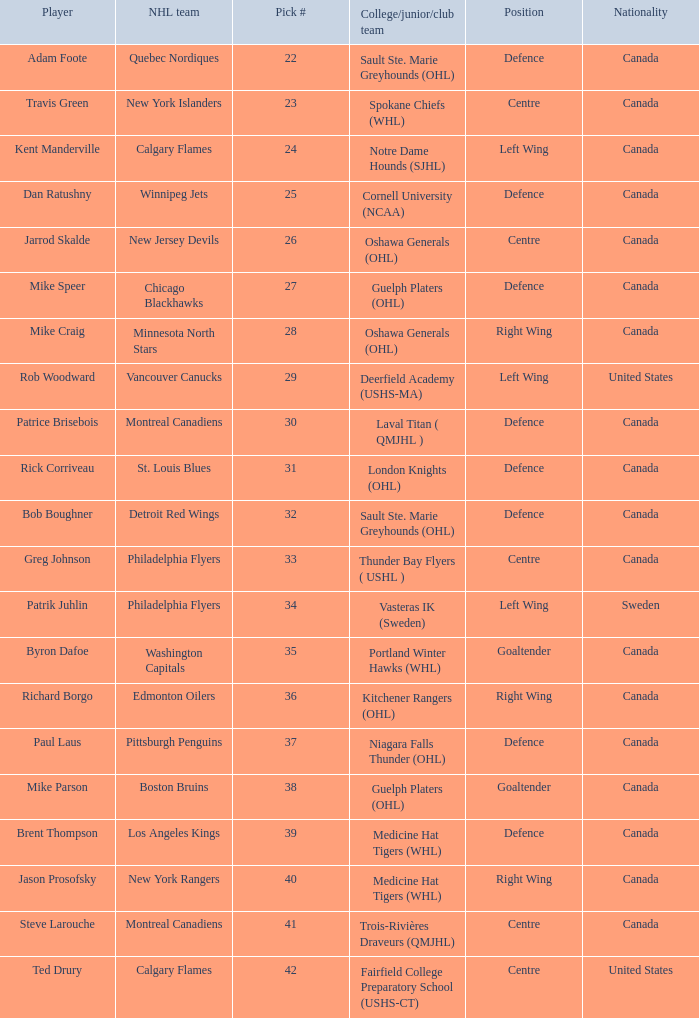Can you give me this table as a dict? {'header': ['Player', 'NHL team', 'Pick #', 'College/junior/club team', 'Position', 'Nationality'], 'rows': [['Adam Foote', 'Quebec Nordiques', '22', 'Sault Ste. Marie Greyhounds (OHL)', 'Defence', 'Canada'], ['Travis Green', 'New York Islanders', '23', 'Spokane Chiefs (WHL)', 'Centre', 'Canada'], ['Kent Manderville', 'Calgary Flames', '24', 'Notre Dame Hounds (SJHL)', 'Left Wing', 'Canada'], ['Dan Ratushny', 'Winnipeg Jets', '25', 'Cornell University (NCAA)', 'Defence', 'Canada'], ['Jarrod Skalde', 'New Jersey Devils', '26', 'Oshawa Generals (OHL)', 'Centre', 'Canada'], ['Mike Speer', 'Chicago Blackhawks', '27', 'Guelph Platers (OHL)', 'Defence', 'Canada'], ['Mike Craig', 'Minnesota North Stars', '28', 'Oshawa Generals (OHL)', 'Right Wing', 'Canada'], ['Rob Woodward', 'Vancouver Canucks', '29', 'Deerfield Academy (USHS-MA)', 'Left Wing', 'United States'], ['Patrice Brisebois', 'Montreal Canadiens', '30', 'Laval Titan ( QMJHL )', 'Defence', 'Canada'], ['Rick Corriveau', 'St. Louis Blues', '31', 'London Knights (OHL)', 'Defence', 'Canada'], ['Bob Boughner', 'Detroit Red Wings', '32', 'Sault Ste. Marie Greyhounds (OHL)', 'Defence', 'Canada'], ['Greg Johnson', 'Philadelphia Flyers', '33', 'Thunder Bay Flyers ( USHL )', 'Centre', 'Canada'], ['Patrik Juhlin', 'Philadelphia Flyers', '34', 'Vasteras IK (Sweden)', 'Left Wing', 'Sweden'], ['Byron Dafoe', 'Washington Capitals', '35', 'Portland Winter Hawks (WHL)', 'Goaltender', 'Canada'], ['Richard Borgo', 'Edmonton Oilers', '36', 'Kitchener Rangers (OHL)', 'Right Wing', 'Canada'], ['Paul Laus', 'Pittsburgh Penguins', '37', 'Niagara Falls Thunder (OHL)', 'Defence', 'Canada'], ['Mike Parson', 'Boston Bruins', '38', 'Guelph Platers (OHL)', 'Goaltender', 'Canada'], ['Brent Thompson', 'Los Angeles Kings', '39', 'Medicine Hat Tigers (WHL)', 'Defence', 'Canada'], ['Jason Prosofsky', 'New York Rangers', '40', 'Medicine Hat Tigers (WHL)', 'Right Wing', 'Canada'], ['Steve Larouche', 'Montreal Canadiens', '41', 'Trois-Rivières Draveurs (QMJHL)', 'Centre', 'Canada'], ['Ted Drury', 'Calgary Flames', '42', 'Fairfield College Preparatory School (USHS-CT)', 'Centre', 'United States']]} What NHL team picked richard borgo? Edmonton Oilers. 